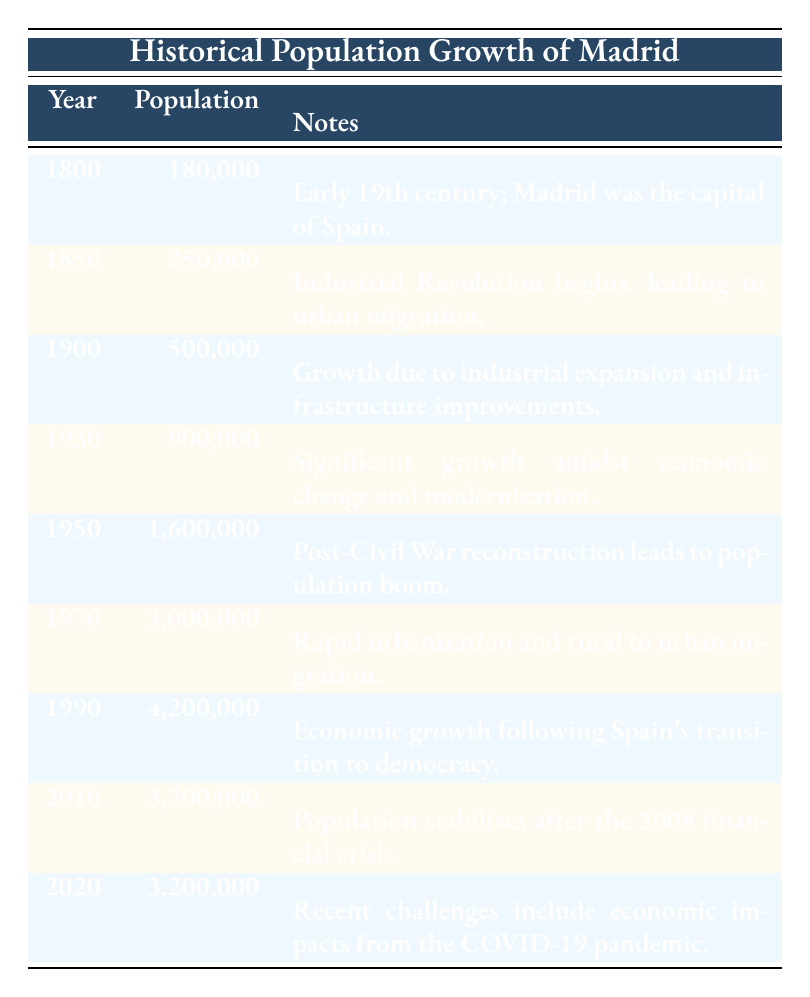What was the population of Madrid in 1900? According to the table, the population of Madrid in the year 1900 is listed as 500,000.
Answer: 500,000 How much did Madrid's population increase from 1850 to 1930? The population in 1850 was 250,000 and in 1930 it was 900,000. The increase can be calculated as 900,000 - 250,000 = 650,000.
Answer: 650,000 Was the population of Madrid stable from 2010 to 2020? The table indicates that the population remained the same in both years, as both are listed at 3,200,000. Therefore, the answer is yes, the population was stable.
Answer: Yes What was the percentage increase in population from 1950 to 1970? The population in 1950 was 1,600,000 and in 1970 it was 3,000,000. The increase is 3,000,000 - 1,600,000 = 1,400,000. To find the percentage, the formula is (Increase/Original)*100. Thus, (1,400,000 / 1,600,000) * 100 = 87.5%.
Answer: 87.5% Which year saw the largest population in Madrid? By reviewing the population figures listed for each year in the table, the largest population recorded is 4,200,000 in the year 1990.
Answer: 1990 What is the average population of Madrid from 1800 to 2020? To find the average, we first sum up the populations for each year: 180,000 + 250,000 + 500,000 + 900,000 + 1,600,000 + 3,000,000 + 4,200,000 + 3,200,000 + 3,200,000 = 17,230,000. Then, we divide by the number of years, which is 9. So, 17,230,000 / 9 = 1,914,444.44. Approximating gives us 1,914,444.
Answer: 1,914,444 Did Madrid’s population double between 1900 and 1930? The population in 1900 was 500,000 and in 1930 it is 900,000. Doubling would mean reaching 1,000,000, which was not achieved. Thus, the statement is false.
Answer: No If urban migration started in 1850, what was the population by 1900? The table states that by 1900, the population reached 500,000, which indicates significant growth due to migration and urbanization that began in 1850.
Answer: 500,000 What was the population trend from 2010 to 2020? The population from 2010 was 3,200,000 and there was no change by 2020, as it remained the same. Thus, the trend can be viewed as stable during that period.
Answer: Stable 